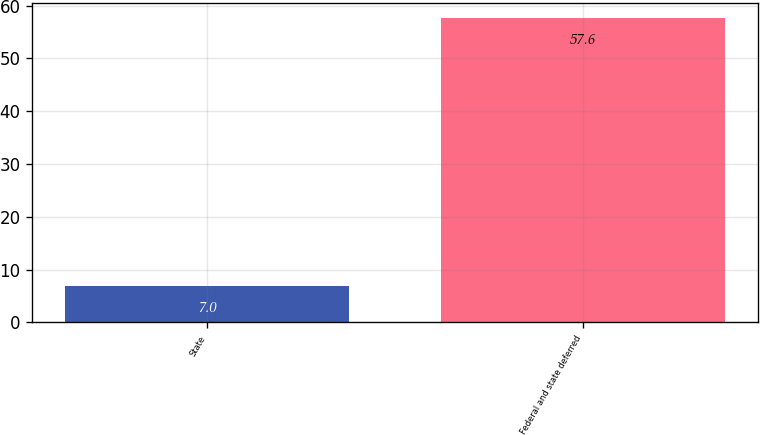<chart> <loc_0><loc_0><loc_500><loc_500><bar_chart><fcel>State<fcel>Federal and state deferred<nl><fcel>7<fcel>57.6<nl></chart> 